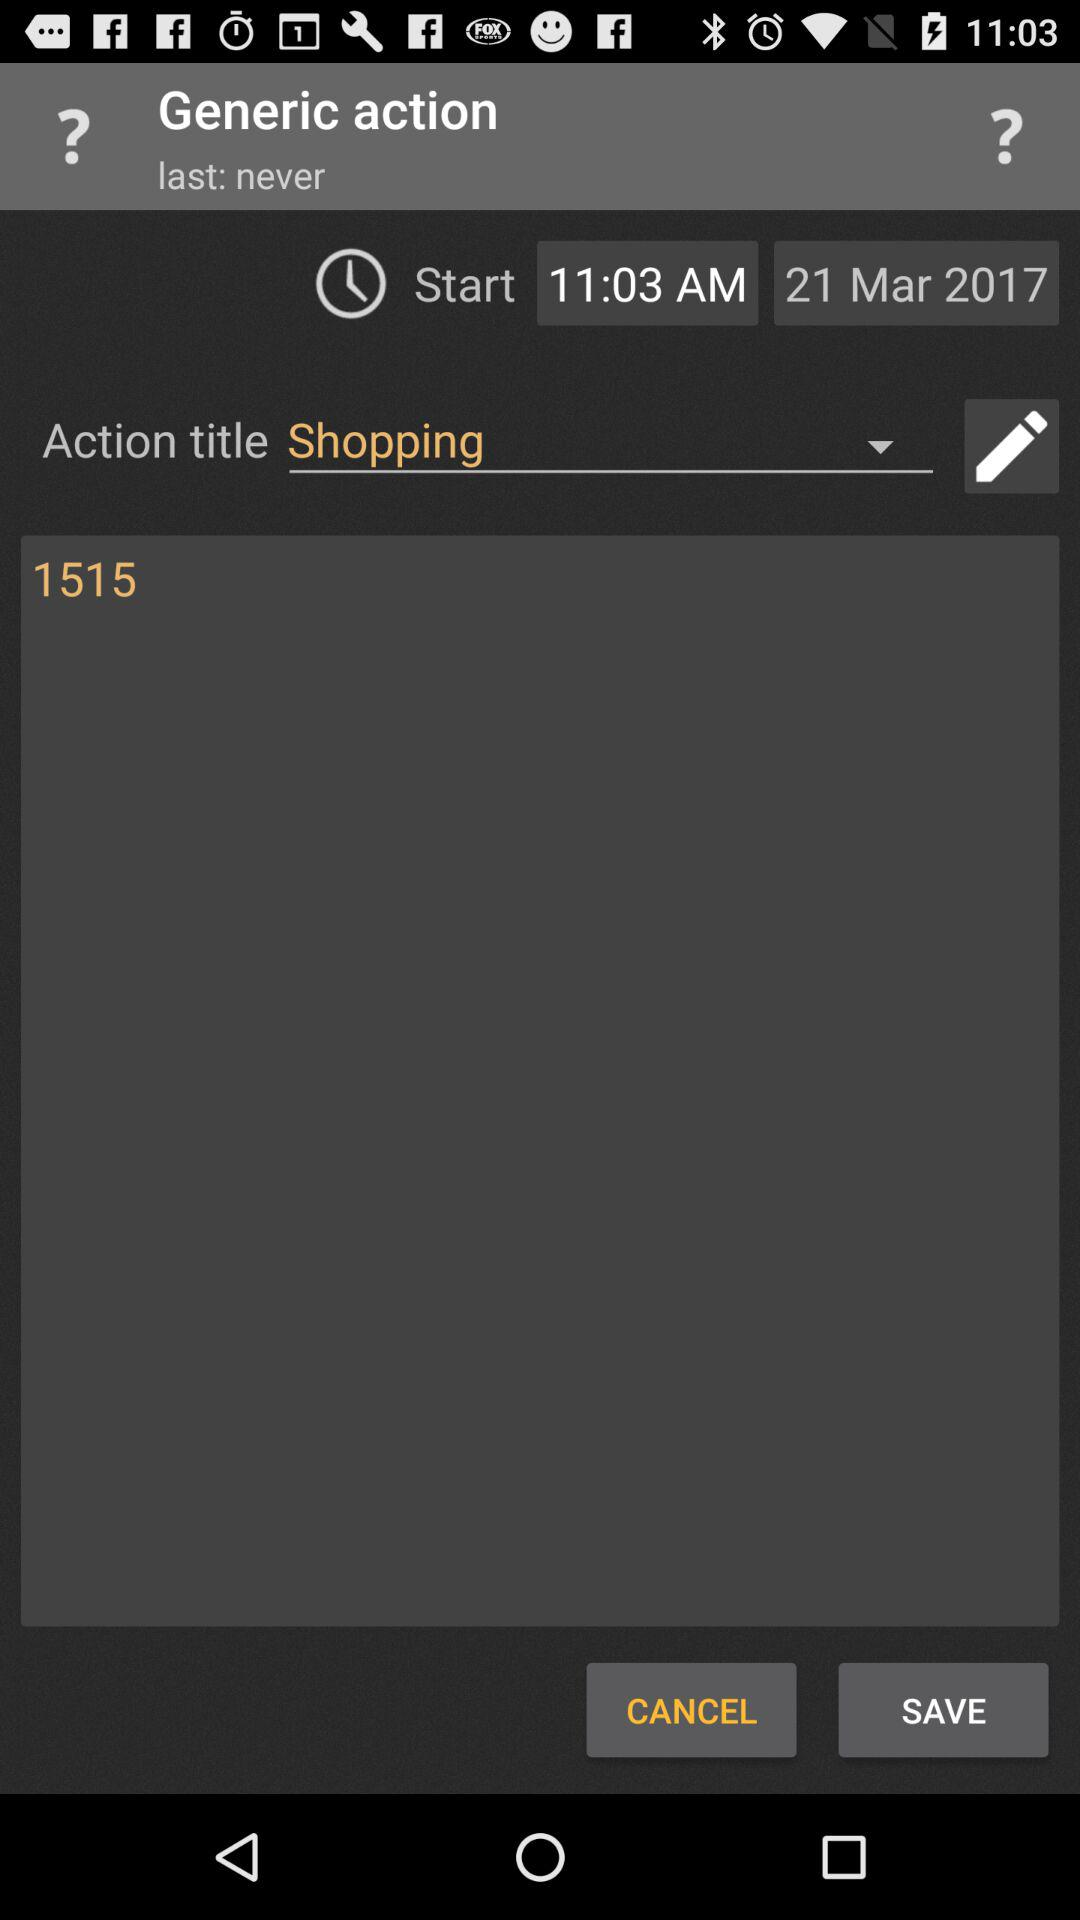What is the mentioned date? The mentioned date is March 21, 2017. 